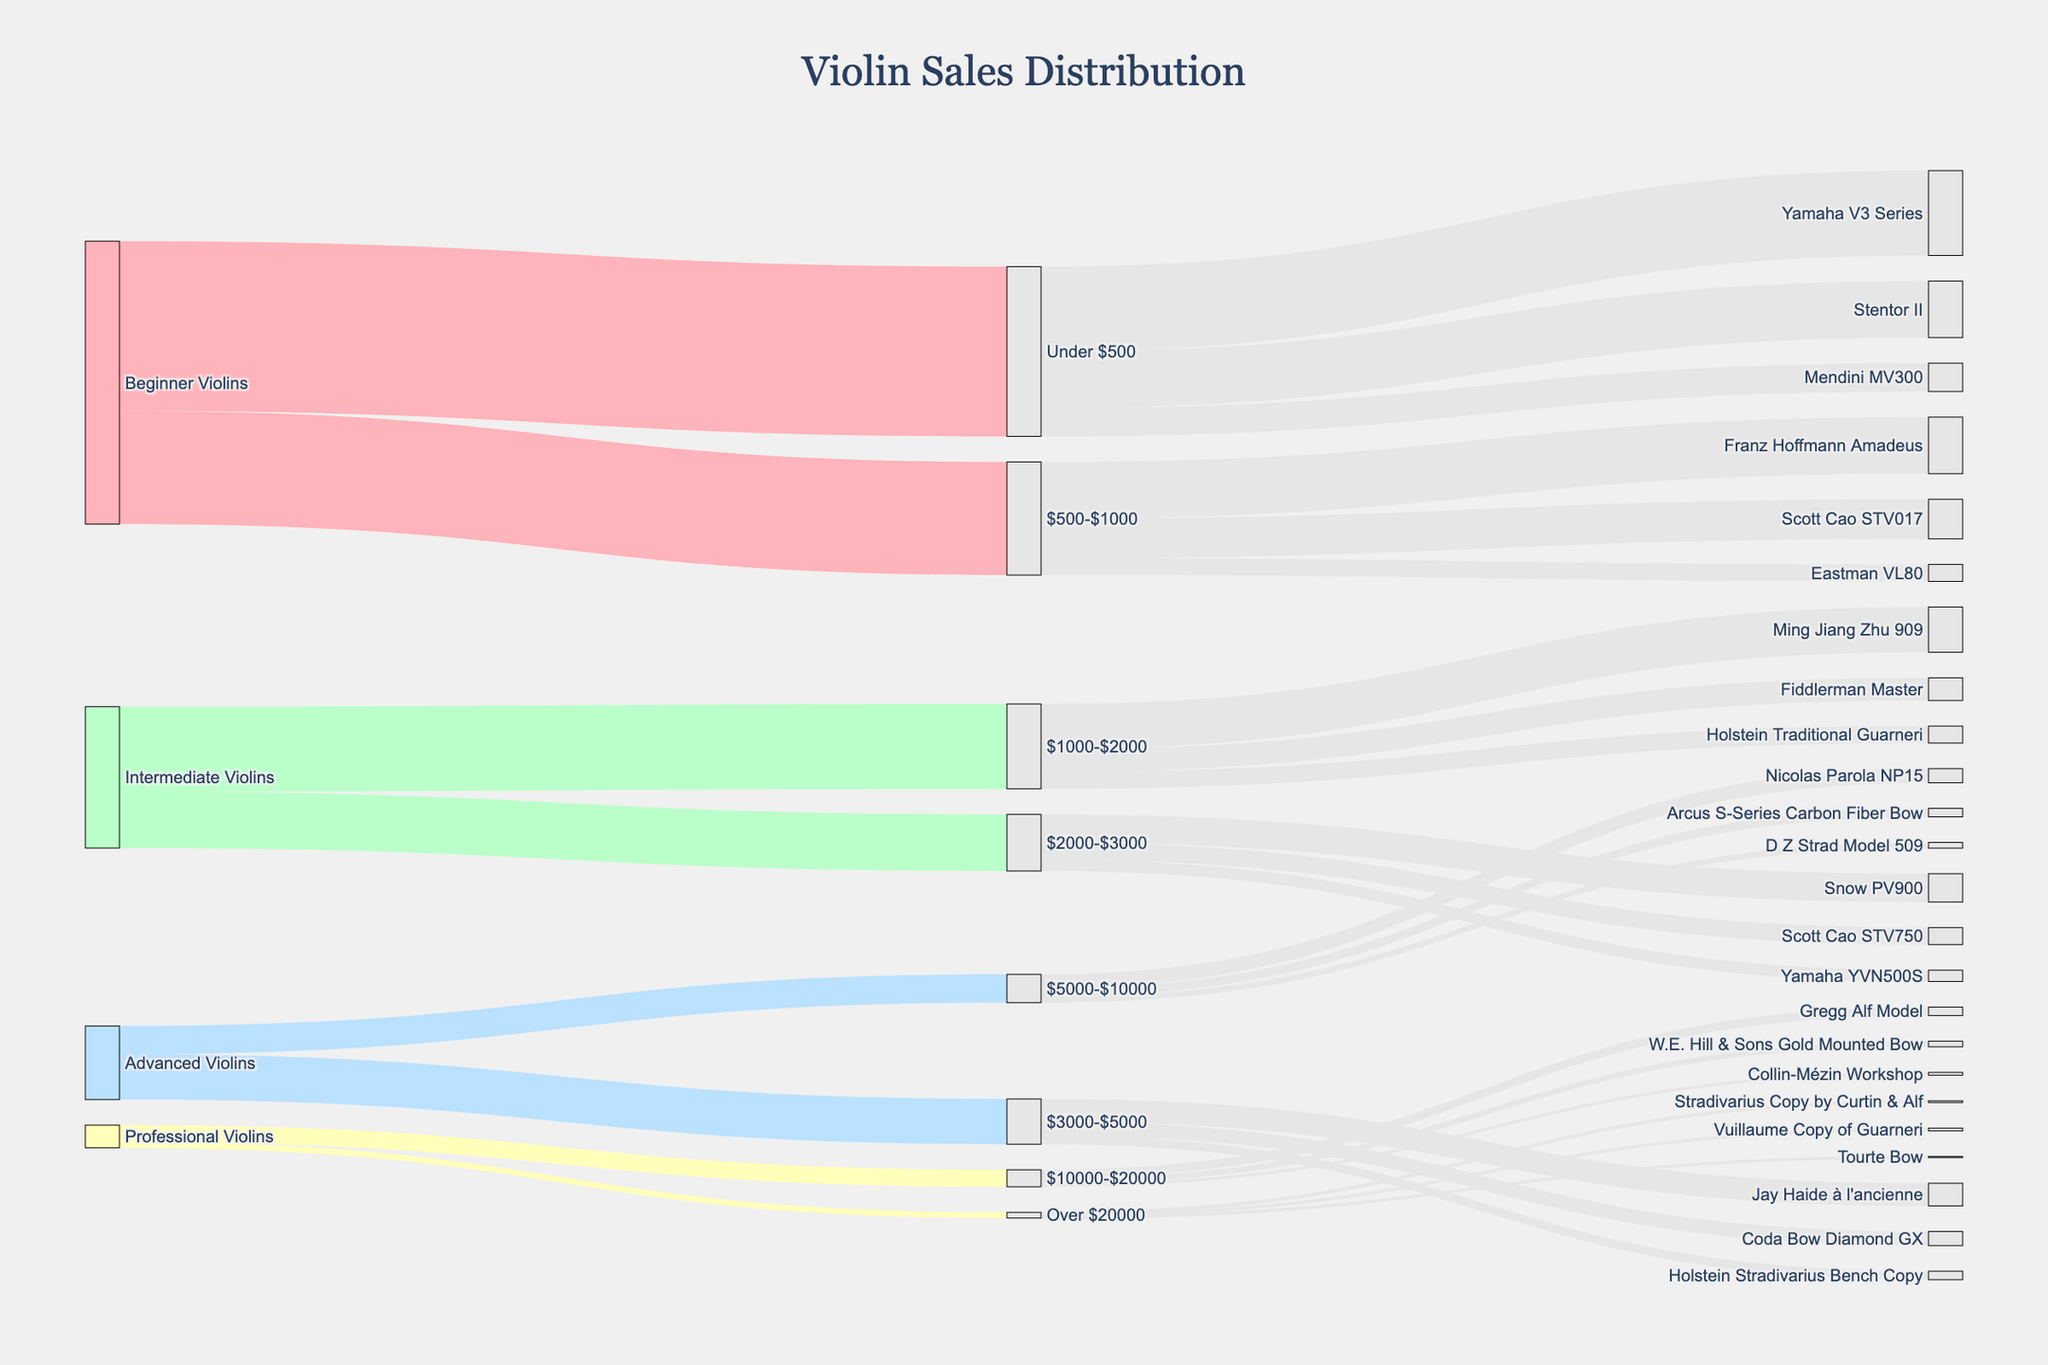What's the title of the chart? The title is located at the top center of the chart and usually provides the main subject of the figure.
Answer: Violin Sales Distribution How many violins are sold for beginner players under $500? Identify the flow from "Beginner Violins" to "Under $500" and read the corresponding value.
Answer: 3000 Which specific violin model has the highest sales value in the "Under $500" category? Observe the links from "Under $500" to the target models and compare their values.
Answer: Yamaha V3 Series How many violins in total are sold in the "$3000-$5000" price range? Sum the values of all links originating from the "$3000-$5000" node.
Answer: 800 What's the difference in sales between "Beginner Violins" in the "$500-$1000" range and "Intermediate Violins" in the "$1000-$2000" range? Subtract the value from "Intermediate Violins" to "$1000-$2000" from the value from "Beginner Violins" to "$500-$1000".
Answer: 500 Which price range sees the highest number of sales for "Professional Violins"? Compare the sales values of the different price ranges linked to "Professional Violins" and identify the maximum.
Answer: $10000-$20000 How many violin sales target "Advanced Violins"? Sum the sales values for all price ranges targeting "Advanced Violins".
Answer: 1300 Are there more sales in the "$500-$1000" range or the "$1000-$2000" range? Compare the total sales values for these two price ranges by summing their respective target links.
Answer: $500-$1000 Which specific violin model has the least sales value in the "Over $20000" category? Observe the links from "Over $20000" to the violin models and determine which has the smallest value.
Answer: Tourte Bow How many specific violin models are represented in the "$1000-$2000" price range? Count the individual target nodes linked from "$1000-$2000".
Answer: 3 